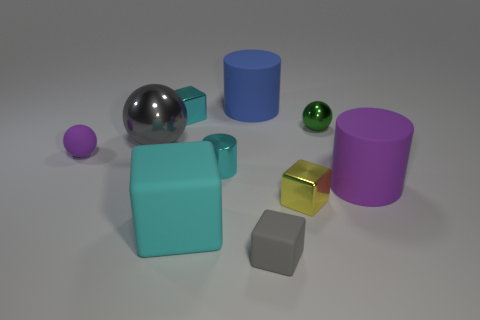Subtract all big blue rubber cylinders. How many cylinders are left? 2 Subtract all green spheres. How many cyan cubes are left? 2 Subtract all yellow cubes. How many cubes are left? 3 Subtract 1 cylinders. How many cylinders are left? 2 Subtract all cylinders. How many objects are left? 7 Subtract all brown blocks. Subtract all purple cylinders. How many blocks are left? 4 Subtract all tiny gray rubber blocks. Subtract all purple matte cubes. How many objects are left? 9 Add 8 metallic blocks. How many metallic blocks are left? 10 Add 1 red cylinders. How many red cylinders exist? 1 Subtract 0 green cylinders. How many objects are left? 10 